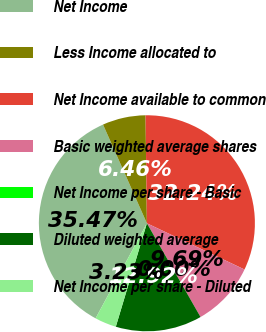Convert chart to OTSL. <chart><loc_0><loc_0><loc_500><loc_500><pie_chart><fcel>Net Income<fcel>Less Income allocated to<fcel>Net Income available to common<fcel>Basic weighted average shares<fcel>Net Income per share - Basic<fcel>Diluted weighted average<fcel>Net Income per share - Diluted<nl><fcel>35.47%<fcel>6.46%<fcel>32.24%<fcel>9.69%<fcel>0.0%<fcel>12.92%<fcel>3.23%<nl></chart> 